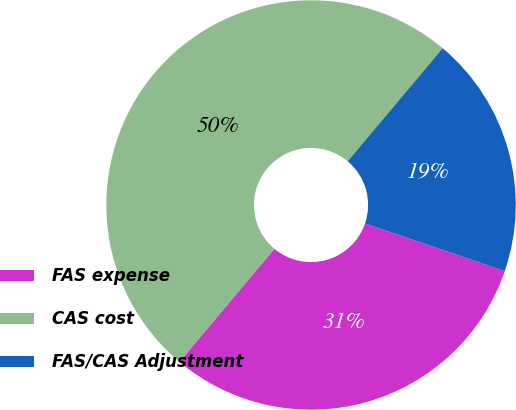Convert chart. <chart><loc_0><loc_0><loc_500><loc_500><pie_chart><fcel>FAS expense<fcel>CAS cost<fcel>FAS/CAS Adjustment<nl><fcel>30.88%<fcel>50.0%<fcel>19.12%<nl></chart> 